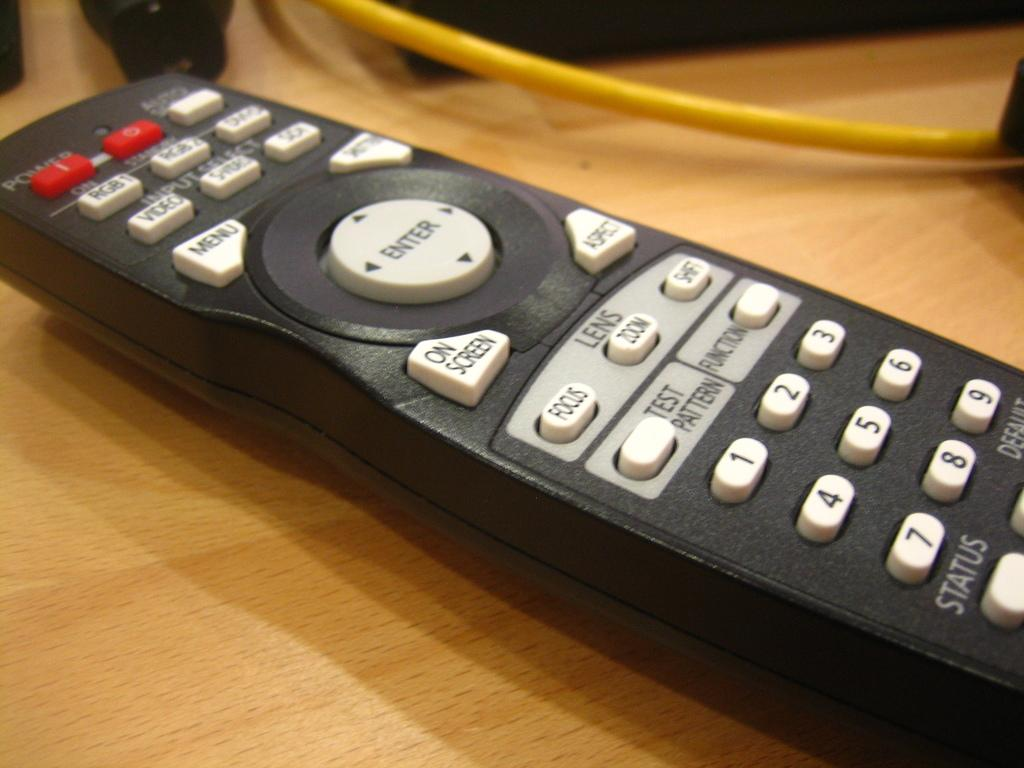<image>
Describe the image concisely. The enter button on a remote is the largest button on the device. 